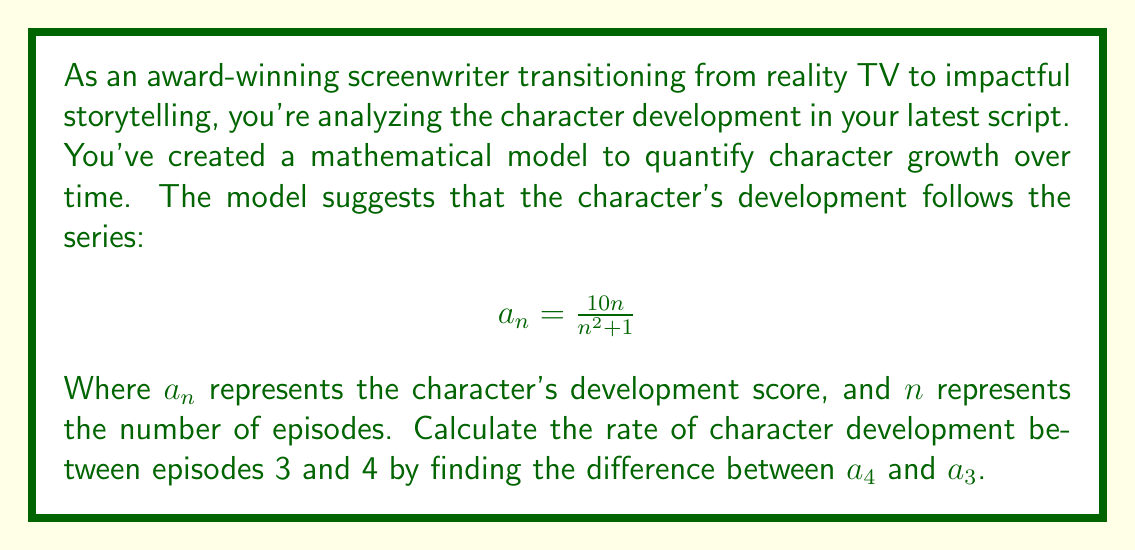Can you answer this question? To solve this problem, we need to calculate $a_3$ and $a_4$, then find their difference. Let's break it down step-by-step:

1. Calculate $a_3$:
   $$a_3 = \frac{10(3)}{3^2 + 1} = \frac{30}{10} = 3$$

2. Calculate $a_4$:
   $$a_4 = \frac{10(4)}{4^2 + 1} = \frac{40}{17}$$

3. Find the difference between $a_4$ and $a_3$:
   $$\text{Rate of development} = a_4 - a_3 = \frac{40}{17} - 3$$

4. To subtract these fractions, we need a common denominator:
   $$\frac{40}{17} - \frac{51}{17} = \frac{40 - 51}{17} = -\frac{11}{17}$$

The negative result indicates that the character's development score actually decreased between episodes 3 and 4, which could represent a dramatic setback or challenge in the character's journey.
Answer: $-\frac{11}{17}$ 